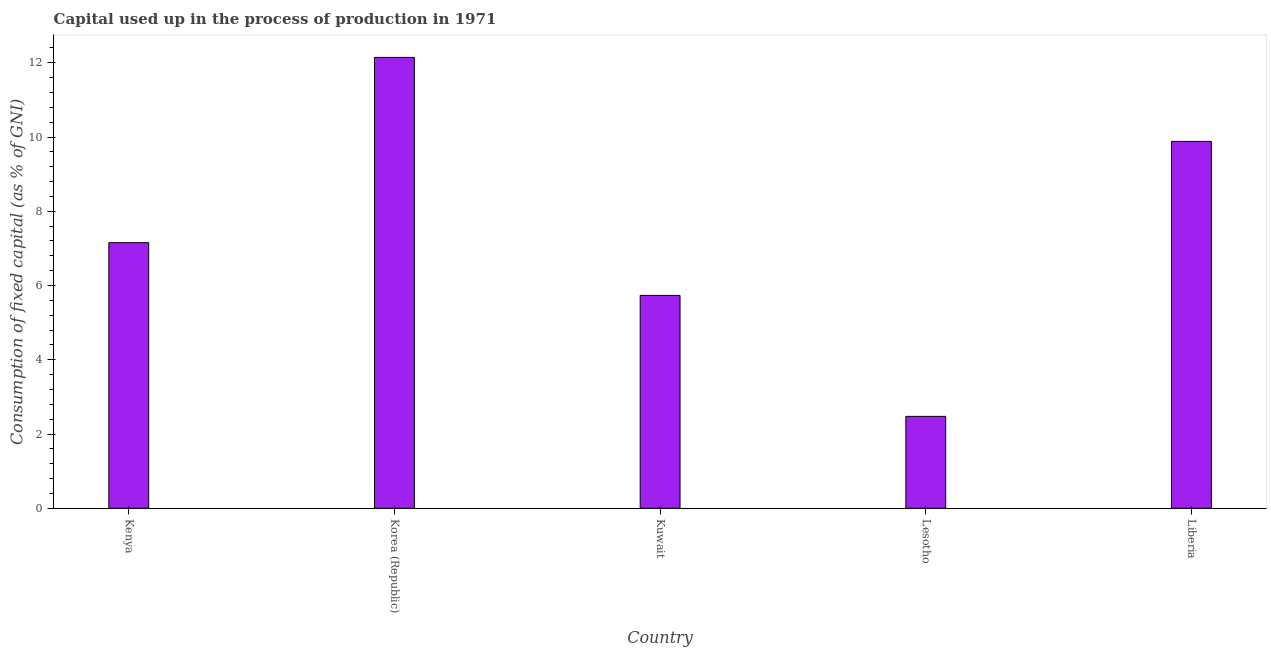Does the graph contain any zero values?
Give a very brief answer. No. Does the graph contain grids?
Provide a short and direct response. No. What is the title of the graph?
Your response must be concise. Capital used up in the process of production in 1971. What is the label or title of the Y-axis?
Provide a succinct answer. Consumption of fixed capital (as % of GNI). What is the consumption of fixed capital in Kuwait?
Make the answer very short. 5.73. Across all countries, what is the maximum consumption of fixed capital?
Give a very brief answer. 12.15. Across all countries, what is the minimum consumption of fixed capital?
Your answer should be very brief. 2.48. In which country was the consumption of fixed capital maximum?
Provide a short and direct response. Korea (Republic). In which country was the consumption of fixed capital minimum?
Offer a terse response. Lesotho. What is the sum of the consumption of fixed capital?
Make the answer very short. 37.39. What is the difference between the consumption of fixed capital in Kenya and Liberia?
Keep it short and to the point. -2.73. What is the average consumption of fixed capital per country?
Provide a succinct answer. 7.48. What is the median consumption of fixed capital?
Offer a very short reply. 7.15. In how many countries, is the consumption of fixed capital greater than 1.2 %?
Offer a very short reply. 5. What is the ratio of the consumption of fixed capital in Kuwait to that in Lesotho?
Offer a terse response. 2.32. Is the consumption of fixed capital in Korea (Republic) less than that in Lesotho?
Provide a succinct answer. No. Is the difference between the consumption of fixed capital in Kenya and Kuwait greater than the difference between any two countries?
Your answer should be very brief. No. What is the difference between the highest and the second highest consumption of fixed capital?
Your answer should be compact. 2.26. Is the sum of the consumption of fixed capital in Kuwait and Liberia greater than the maximum consumption of fixed capital across all countries?
Give a very brief answer. Yes. What is the difference between the highest and the lowest consumption of fixed capital?
Give a very brief answer. 9.67. How many bars are there?
Your answer should be very brief. 5. What is the Consumption of fixed capital (as % of GNI) in Kenya?
Your response must be concise. 7.15. What is the Consumption of fixed capital (as % of GNI) of Korea (Republic)?
Offer a very short reply. 12.15. What is the Consumption of fixed capital (as % of GNI) in Kuwait?
Give a very brief answer. 5.73. What is the Consumption of fixed capital (as % of GNI) in Lesotho?
Your answer should be compact. 2.48. What is the Consumption of fixed capital (as % of GNI) of Liberia?
Offer a very short reply. 9.88. What is the difference between the Consumption of fixed capital (as % of GNI) in Kenya and Korea (Republic)?
Provide a succinct answer. -4.99. What is the difference between the Consumption of fixed capital (as % of GNI) in Kenya and Kuwait?
Your response must be concise. 1.42. What is the difference between the Consumption of fixed capital (as % of GNI) in Kenya and Lesotho?
Offer a very short reply. 4.68. What is the difference between the Consumption of fixed capital (as % of GNI) in Kenya and Liberia?
Your answer should be very brief. -2.73. What is the difference between the Consumption of fixed capital (as % of GNI) in Korea (Republic) and Kuwait?
Keep it short and to the point. 6.41. What is the difference between the Consumption of fixed capital (as % of GNI) in Korea (Republic) and Lesotho?
Your response must be concise. 9.67. What is the difference between the Consumption of fixed capital (as % of GNI) in Korea (Republic) and Liberia?
Your answer should be very brief. 2.26. What is the difference between the Consumption of fixed capital (as % of GNI) in Kuwait and Lesotho?
Offer a terse response. 3.26. What is the difference between the Consumption of fixed capital (as % of GNI) in Kuwait and Liberia?
Provide a succinct answer. -4.15. What is the difference between the Consumption of fixed capital (as % of GNI) in Lesotho and Liberia?
Keep it short and to the point. -7.41. What is the ratio of the Consumption of fixed capital (as % of GNI) in Kenya to that in Korea (Republic)?
Make the answer very short. 0.59. What is the ratio of the Consumption of fixed capital (as % of GNI) in Kenya to that in Kuwait?
Offer a terse response. 1.25. What is the ratio of the Consumption of fixed capital (as % of GNI) in Kenya to that in Lesotho?
Offer a very short reply. 2.89. What is the ratio of the Consumption of fixed capital (as % of GNI) in Kenya to that in Liberia?
Your answer should be compact. 0.72. What is the ratio of the Consumption of fixed capital (as % of GNI) in Korea (Republic) to that in Kuwait?
Your answer should be compact. 2.12. What is the ratio of the Consumption of fixed capital (as % of GNI) in Korea (Republic) to that in Lesotho?
Offer a terse response. 4.91. What is the ratio of the Consumption of fixed capital (as % of GNI) in Korea (Republic) to that in Liberia?
Give a very brief answer. 1.23. What is the ratio of the Consumption of fixed capital (as % of GNI) in Kuwait to that in Lesotho?
Give a very brief answer. 2.32. What is the ratio of the Consumption of fixed capital (as % of GNI) in Kuwait to that in Liberia?
Ensure brevity in your answer.  0.58. What is the ratio of the Consumption of fixed capital (as % of GNI) in Lesotho to that in Liberia?
Your response must be concise. 0.25. 